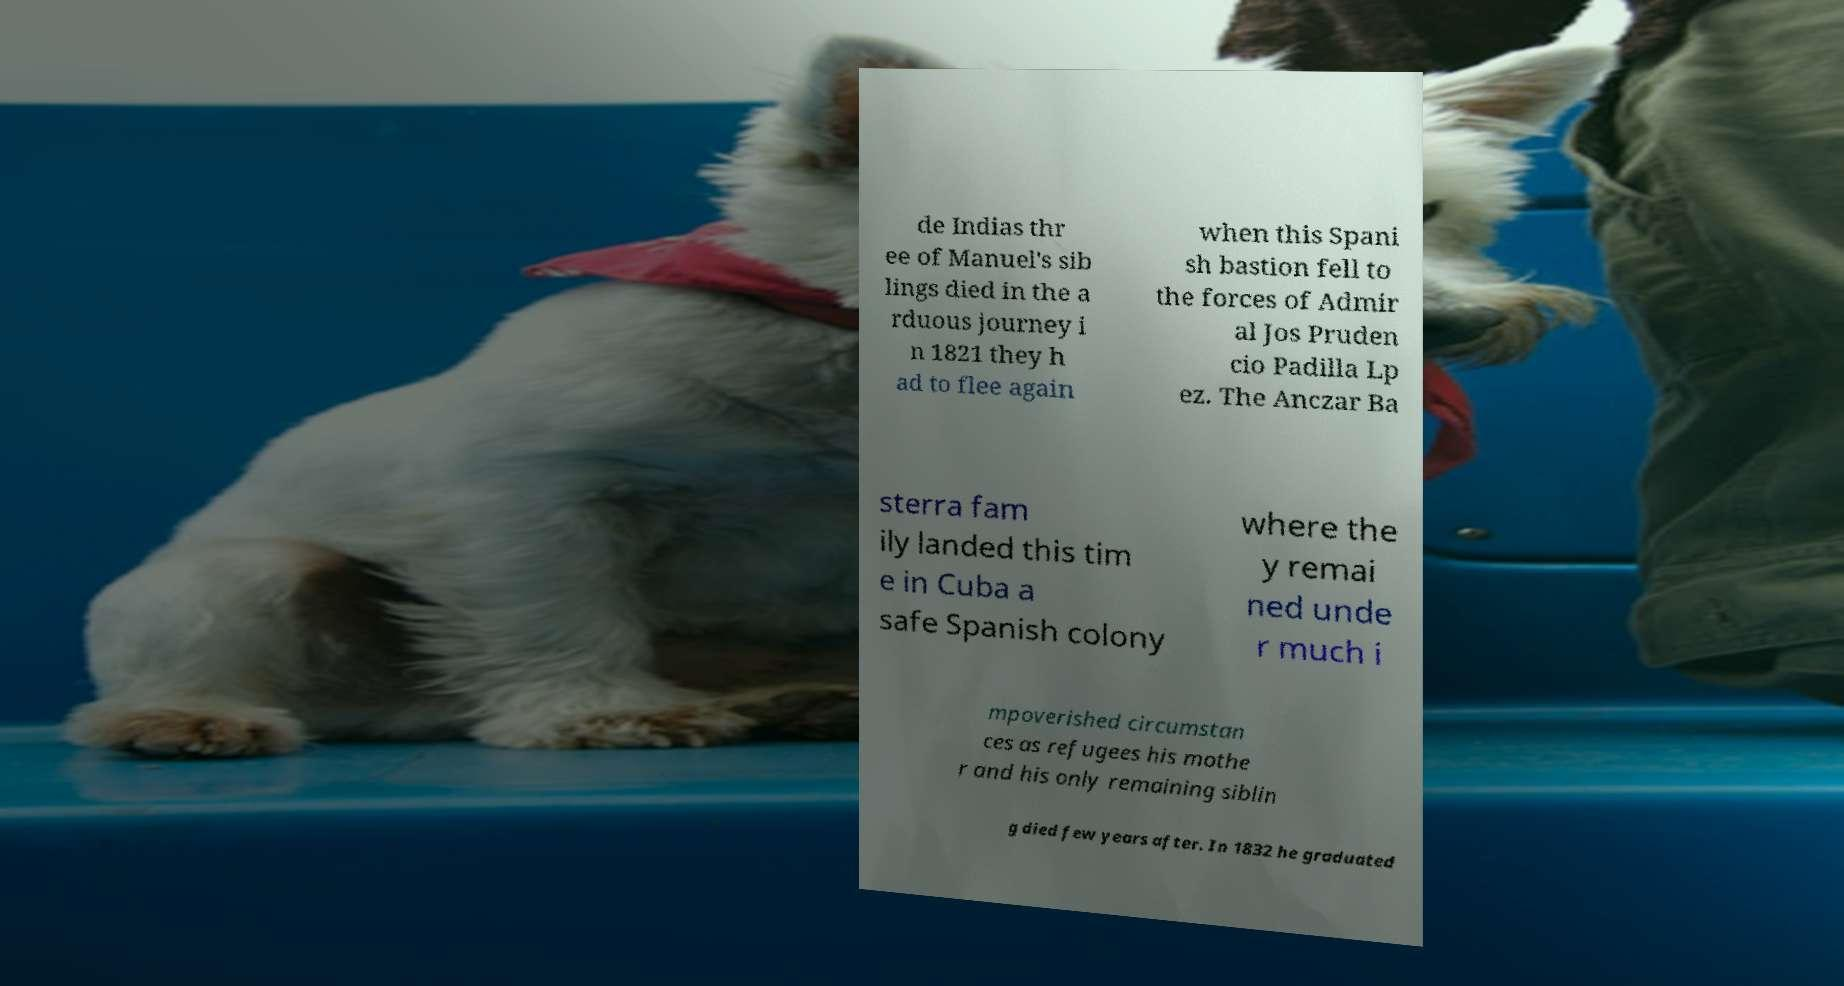Could you extract and type out the text from this image? de Indias thr ee of Manuel's sib lings died in the a rduous journey i n 1821 they h ad to flee again when this Spani sh bastion fell to the forces of Admir al Jos Pruden cio Padilla Lp ez. The Anczar Ba sterra fam ily landed this tim e in Cuba a safe Spanish colony where the y remai ned unde r much i mpoverished circumstan ces as refugees his mothe r and his only remaining siblin g died few years after. In 1832 he graduated 